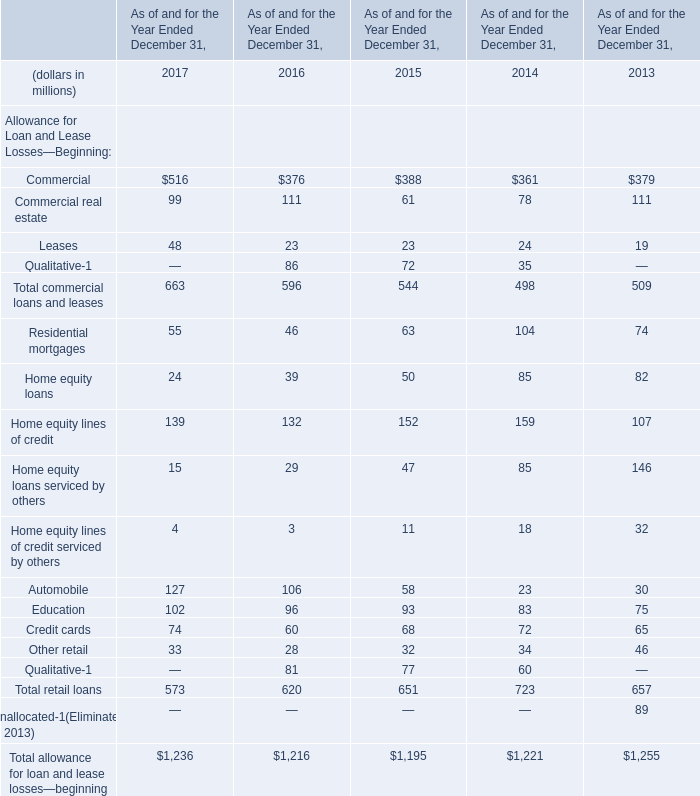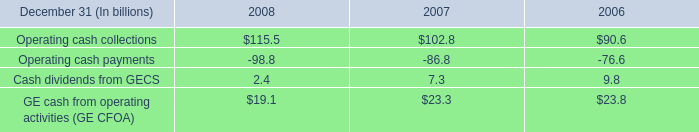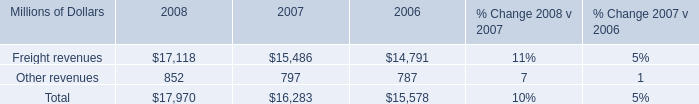The total amount of which section ranks first in 2017? (in million) 
Answer: 573. 